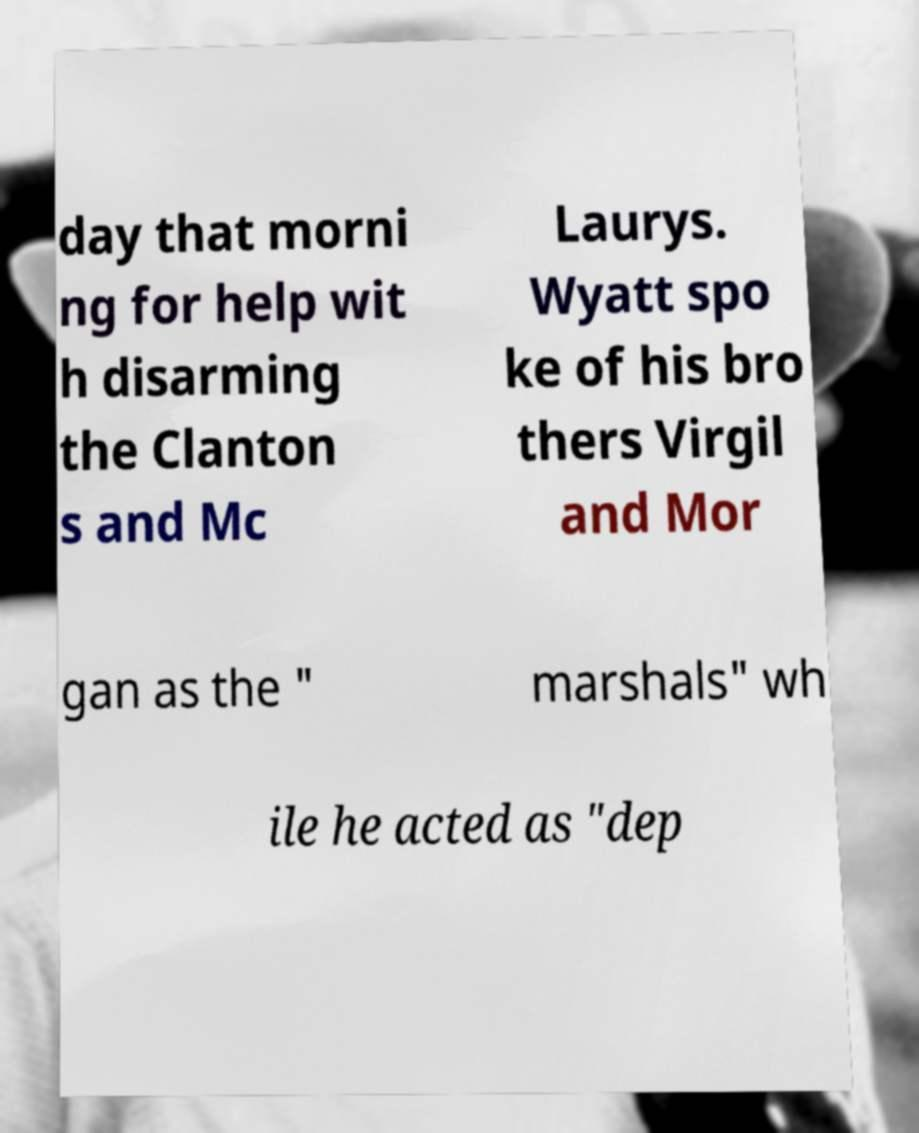For documentation purposes, I need the text within this image transcribed. Could you provide that? day that morni ng for help wit h disarming the Clanton s and Mc Laurys. Wyatt spo ke of his bro thers Virgil and Mor gan as the " marshals" wh ile he acted as "dep 